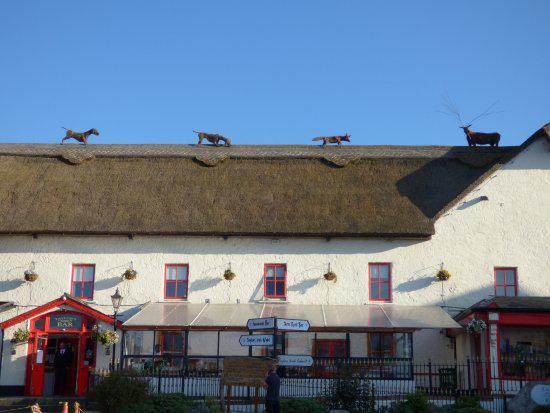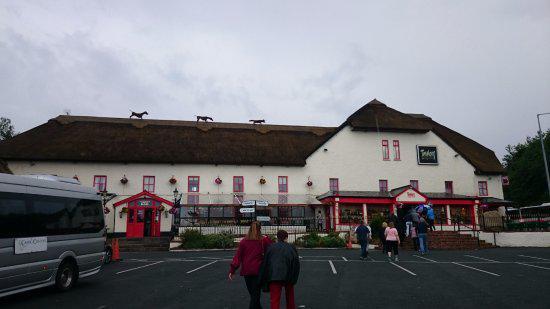The first image is the image on the left, the second image is the image on the right. For the images shown, is this caption "In at least one image, there are at least two homes with white walls." true? Answer yes or no. No. The first image is the image on the left, the second image is the image on the right. Evaluate the accuracy of this statement regarding the images: "People are standing in front of one of the buildings.". Is it true? Answer yes or no. Yes. 